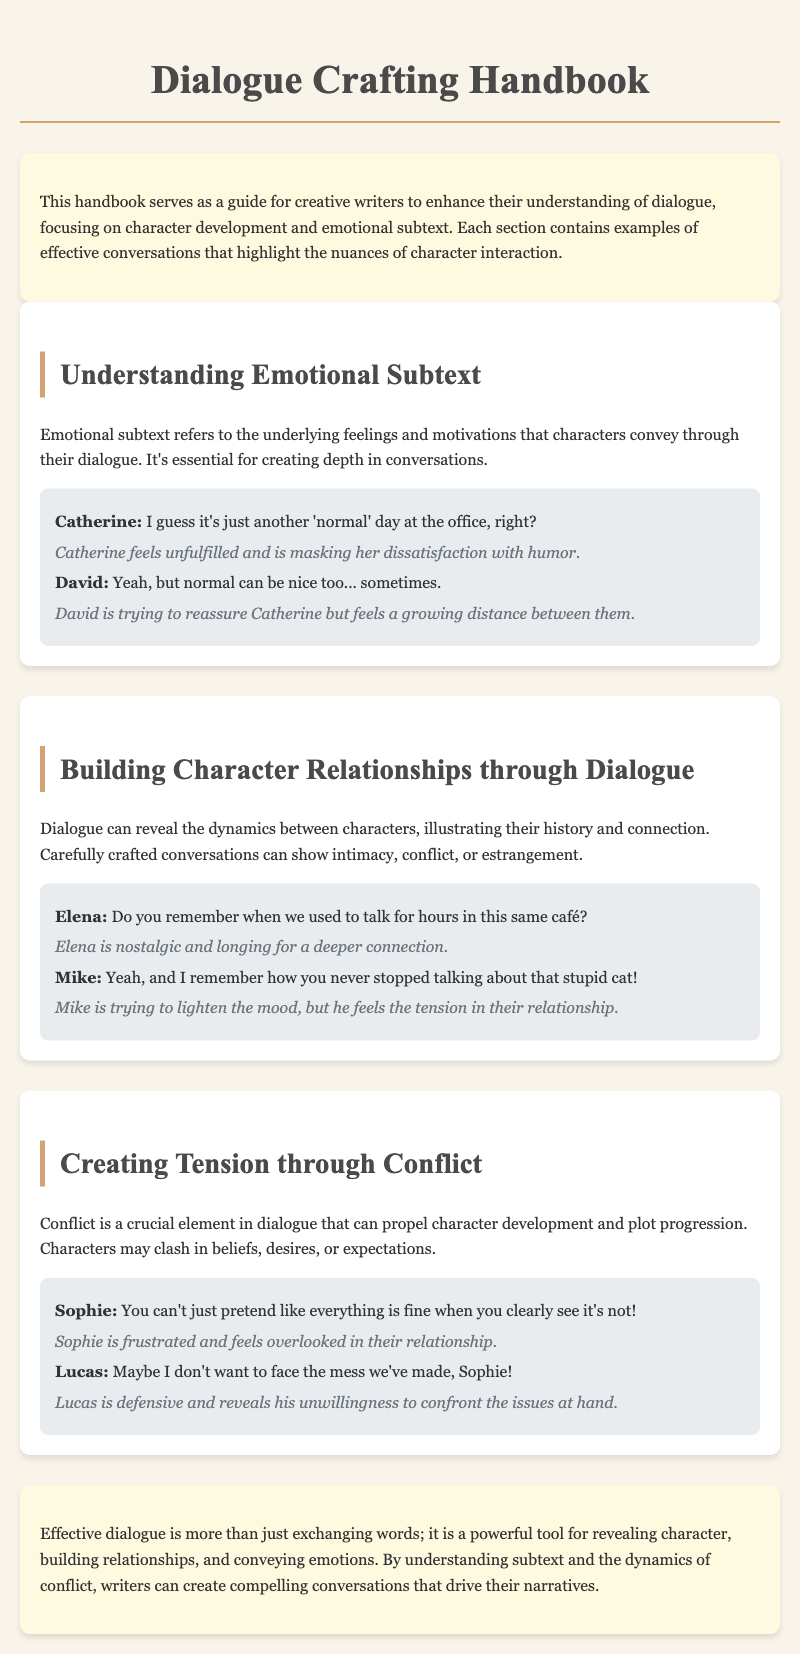What is the title of the handbook? The title is provided in the header of the document.
Answer: Dialogue Crafting Handbook What is the first section about? The first section discusses the concept of emotional subtext in dialogue.
Answer: Understanding Emotional Subtext Who are the characters in the example of emotional subtext? The example features specific characters engaged in dialogue.
Answer: Catherine and David What tension is present in the example of conflict? The example illustrates a specific feeling of frustration within the dialogue.
Answer: Frustration What emotional desire does Elena express? Elena's dialogue conveys a longing for something specific in the past.
Answer: Nostalgia How many sections are there in the handbook? The handbook contains a specific number of sections that focus on different aspects of dialogue.
Answer: Three What does effective dialogue reveal according to the conclusion? The conclusion outlines what effective dialogue can showcase in storytelling.
Answer: Character and emotions What type of writing does this handbook cater to? The handbook is designed for a specific group of writers.
Answer: Creative writers 